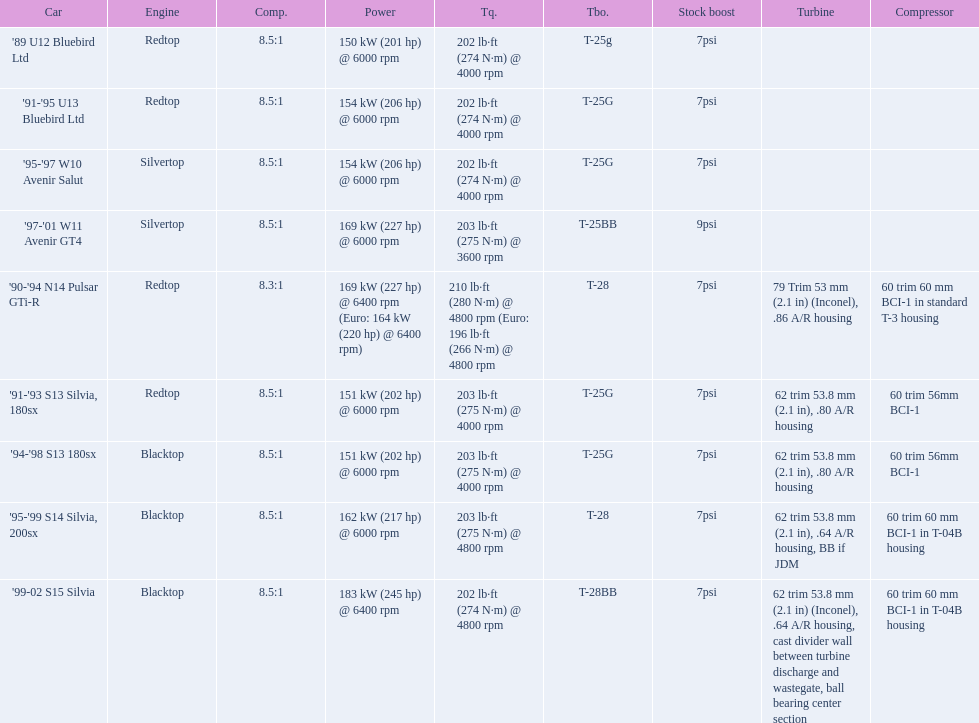Which cars list turbine details? '90-'94 N14 Pulsar GTi-R, '91-'93 S13 Silvia, 180sx, '94-'98 S13 180sx, '95-'99 S14 Silvia, 200sx, '99-02 S15 Silvia. Which of these hit their peak hp at the highest rpm? '90-'94 N14 Pulsar GTi-R, '99-02 S15 Silvia. Of those what is the compression of the only engine that isn't blacktop?? 8.3:1. 